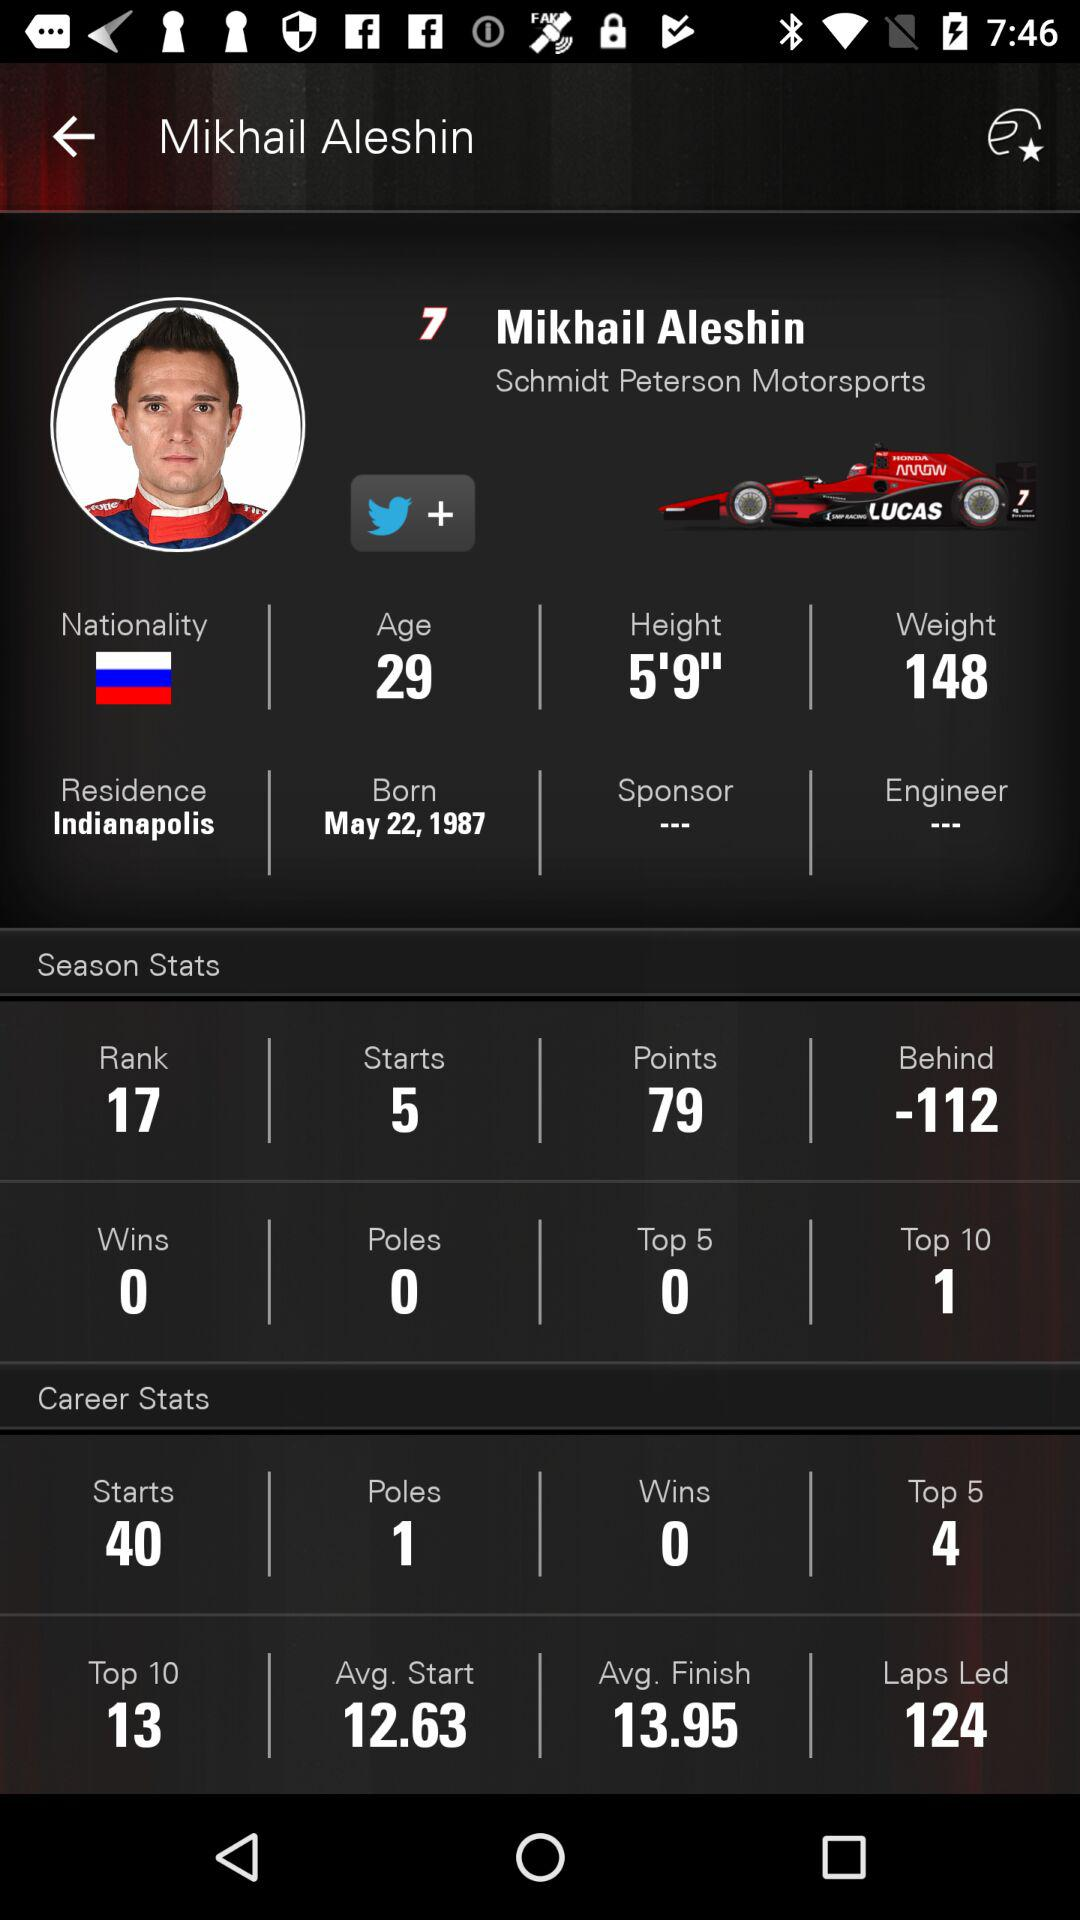How many times has Mikhail Aleshin been in the top 5 in his career? In his career, Mikhail Aleshin has been in the top 5 four times. 